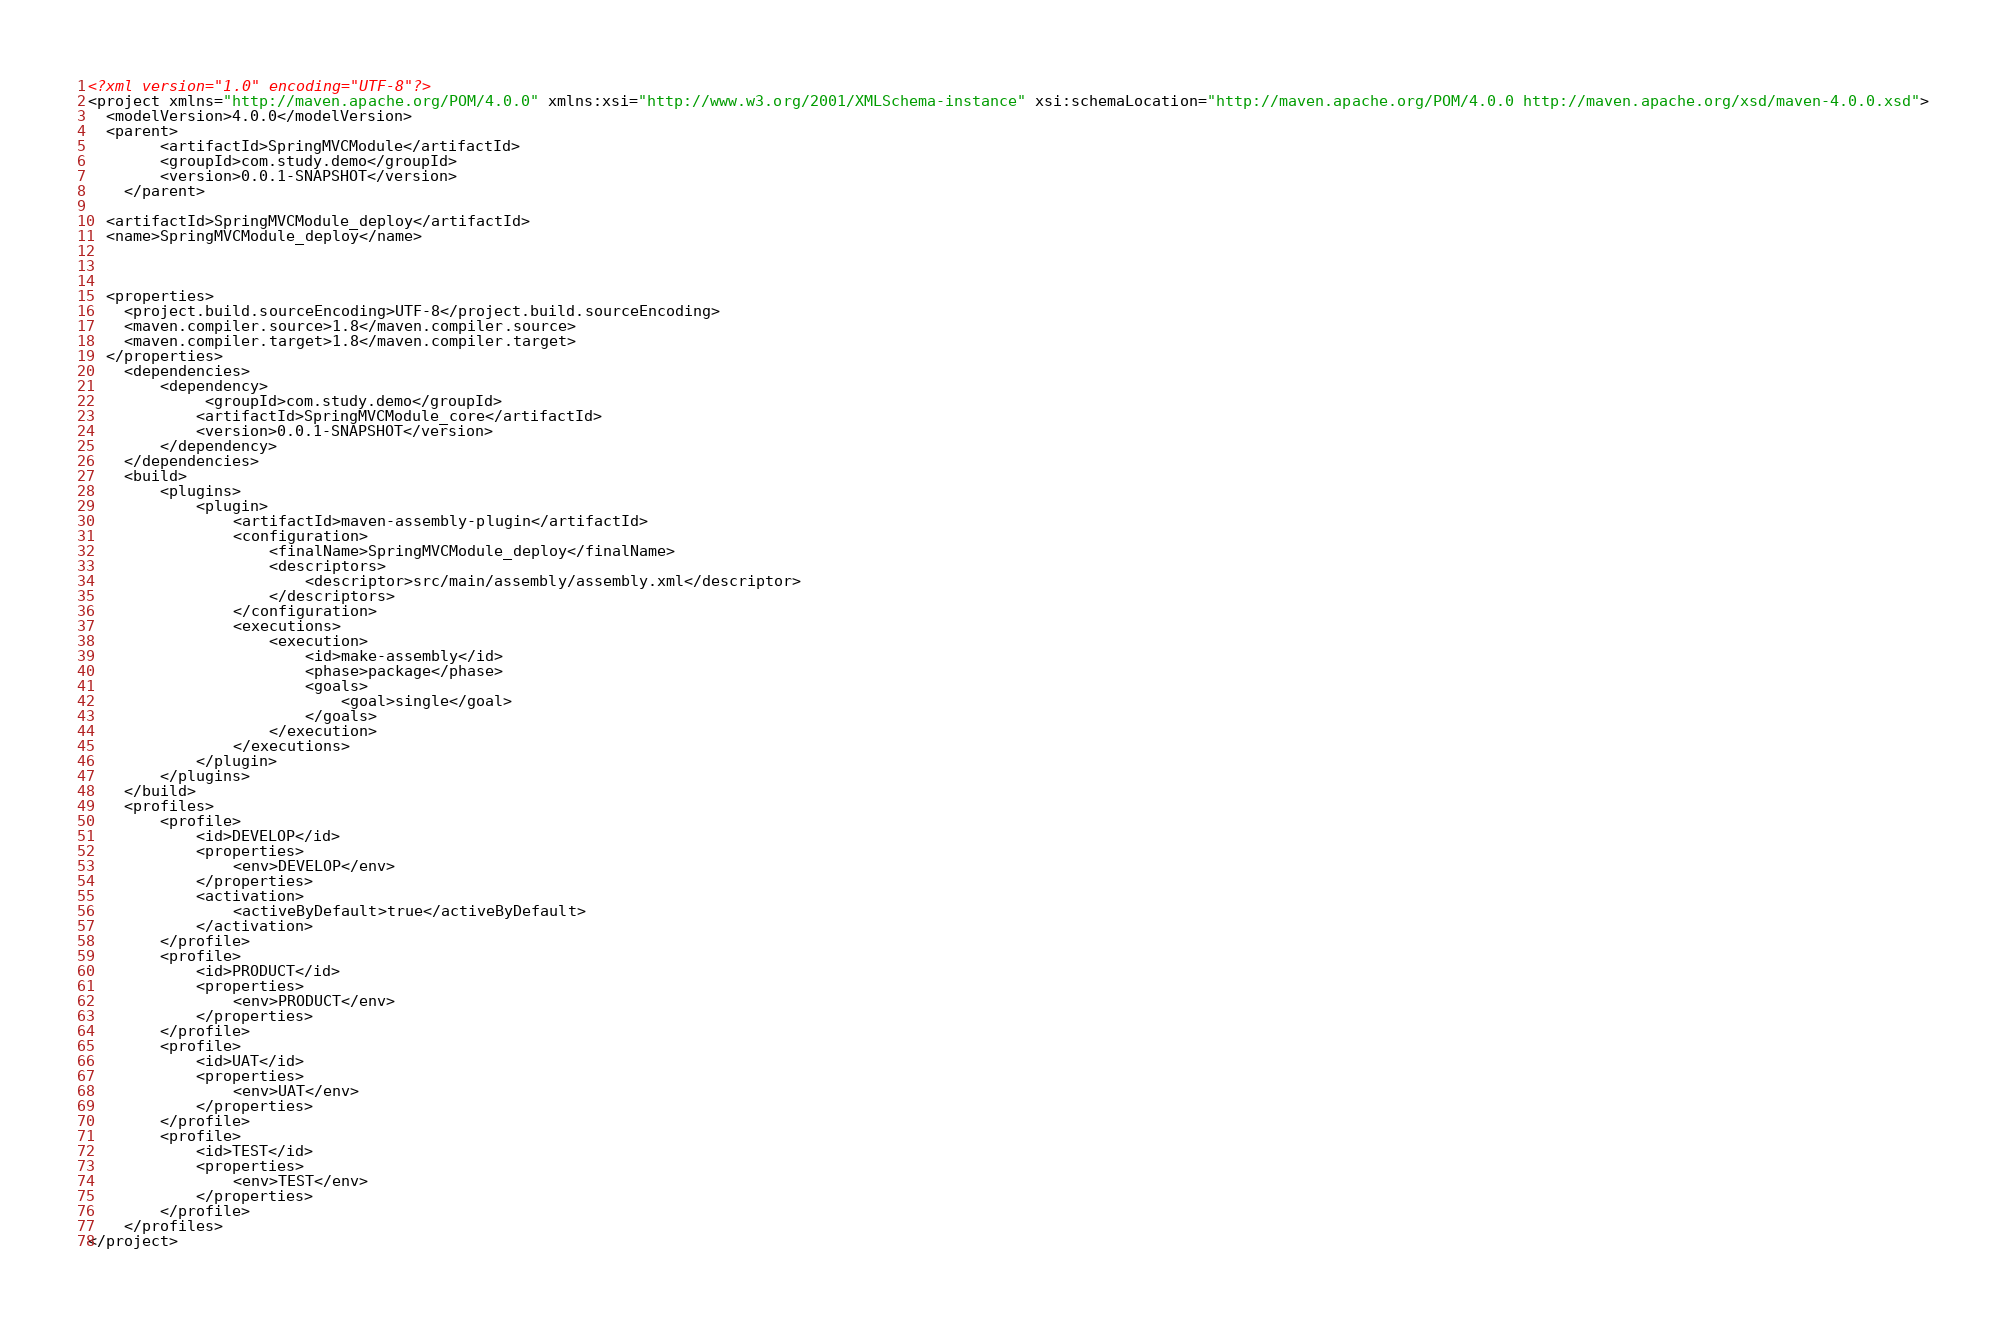Convert code to text. <code><loc_0><loc_0><loc_500><loc_500><_XML_><?xml version="1.0" encoding="UTF-8"?>
<project xmlns="http://maven.apache.org/POM/4.0.0" xmlns:xsi="http://www.w3.org/2001/XMLSchema-instance" xsi:schemaLocation="http://maven.apache.org/POM/4.0.0 http://maven.apache.org/xsd/maven-4.0.0.xsd">
  <modelVersion>4.0.0</modelVersion>
  <parent>
        <artifactId>SpringMVCModule</artifactId>
        <groupId>com.study.demo</groupId>
        <version>0.0.1-SNAPSHOT</version>
    </parent>

  <artifactId>SpringMVCModule_deploy</artifactId>
  <name>SpringMVCModule_deploy</name>



  <properties>
    <project.build.sourceEncoding>UTF-8</project.build.sourceEncoding>
    <maven.compiler.source>1.8</maven.compiler.source>
    <maven.compiler.target>1.8</maven.compiler.target>
  </properties>
	<dependencies>
		<dependency>
			 <groupId>com.study.demo</groupId>
			<artifactId>SpringMVCModule_core</artifactId>
			<version>0.0.1-SNAPSHOT</version>
		</dependency>
	</dependencies>
	<build>
		<plugins>
			<plugin>
				<artifactId>maven-assembly-plugin</artifactId>
				<configuration>
					<finalName>SpringMVCModule_deploy</finalName>
					<descriptors>
						<descriptor>src/main/assembly/assembly.xml</descriptor>
					</descriptors>
				</configuration>
				<executions>
					<execution>
						<id>make-assembly</id>
						<phase>package</phase>
						<goals>
							<goal>single</goal>
						</goals>
					</execution>
				</executions>
			</plugin>
		</plugins>
	</build>
	<profiles>
		<profile>
			<id>DEVELOP</id>
			<properties>
				<env>DEVELOP</env>
			</properties>
			<activation>
				<activeByDefault>true</activeByDefault>
			</activation>
		</profile>
		<profile>
			<id>PRODUCT</id>
			<properties>
				<env>PRODUCT</env>
			</properties>
		</profile>
		<profile>
			<id>UAT</id>
			<properties>
				<env>UAT</env>
			</properties>
		</profile>
		<profile>
			<id>TEST</id>
			<properties>
				<env>TEST</env>
			</properties>
		</profile>
	</profiles>
</project>
</code> 